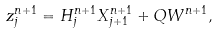<formula> <loc_0><loc_0><loc_500><loc_500>z _ { j } ^ { n + 1 } = H ^ { n + 1 } _ { j } X ^ { n + 1 } _ { j + 1 } + Q W ^ { n + 1 } ,</formula> 